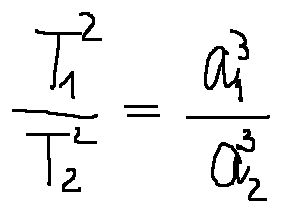Convert formula to latex. <formula><loc_0><loc_0><loc_500><loc_500>\frac { T _ { 1 } ^ { 2 } } { T _ { 2 } ^ { 2 } } = \frac { a _ { 1 } ^ { 3 } } { a _ { 2 } ^ { 3 } }</formula> 